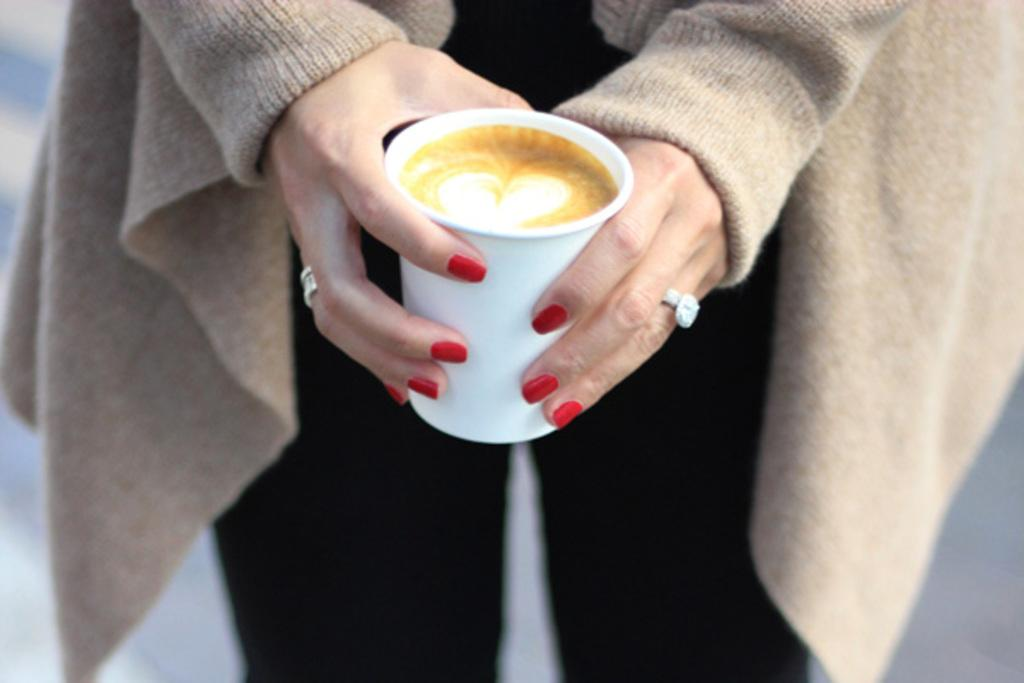What is the main subject of the image? There is a person in the image. What is the person holding in the image? The person is holding a coffee cup. Where is the person and the coffee cup located in the image? The person and the coffee cup are in the center of the image. What type of camp can be seen in the background of the image? There is no camp visible in the image; it only features a person holding a coffee cup in the center. How many attempts did the person make before successfully holding the coffee cup in the image? The image does not provide information about any attempts made by the person; it only shows the person holding the coffee cup. 